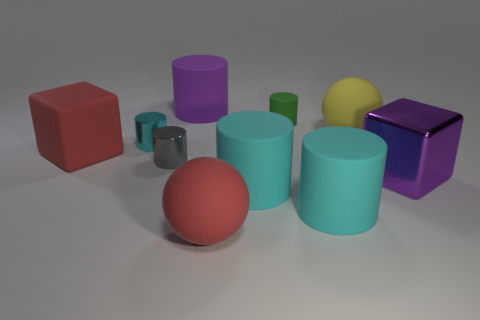Are there more big red rubber objects that are to the right of the small green rubber cylinder than tiny green cylinders that are in front of the small gray thing?
Your answer should be very brief. No. What is the color of the small cylinder that is behind the yellow rubber ball?
Provide a succinct answer. Green. Is there a large gray thing that has the same shape as the small gray object?
Provide a short and direct response. No. How many blue objects are either large cubes or tiny matte things?
Provide a succinct answer. 0. Are there any other red cubes that have the same size as the red rubber cube?
Provide a short and direct response. No. What number of large yellow metal balls are there?
Your answer should be compact. 0. What number of big objects are objects or cyan metal things?
Keep it short and to the point. 7. What color is the small metal cylinder in front of the cyan cylinder on the left side of the purple rubber cylinder to the right of the gray metal thing?
Give a very brief answer. Gray. How many other objects are there of the same color as the small matte cylinder?
Give a very brief answer. 0. What number of metallic things are green spheres or cylinders?
Make the answer very short. 2. 